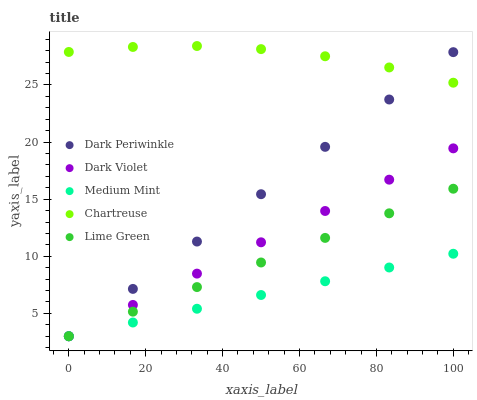Does Medium Mint have the minimum area under the curve?
Answer yes or no. Yes. Does Chartreuse have the maximum area under the curve?
Answer yes or no. Yes. Does Lime Green have the minimum area under the curve?
Answer yes or no. No. Does Lime Green have the maximum area under the curve?
Answer yes or no. No. Is Lime Green the smoothest?
Answer yes or no. Yes. Is Chartreuse the roughest?
Answer yes or no. Yes. Is Chartreuse the smoothest?
Answer yes or no. No. Is Lime Green the roughest?
Answer yes or no. No. Does Medium Mint have the lowest value?
Answer yes or no. Yes. Does Chartreuse have the lowest value?
Answer yes or no. No. Does Chartreuse have the highest value?
Answer yes or no. Yes. Does Lime Green have the highest value?
Answer yes or no. No. Is Lime Green less than Chartreuse?
Answer yes or no. Yes. Is Chartreuse greater than Lime Green?
Answer yes or no. Yes. Does Dark Periwinkle intersect Dark Violet?
Answer yes or no. Yes. Is Dark Periwinkle less than Dark Violet?
Answer yes or no. No. Is Dark Periwinkle greater than Dark Violet?
Answer yes or no. No. Does Lime Green intersect Chartreuse?
Answer yes or no. No. 